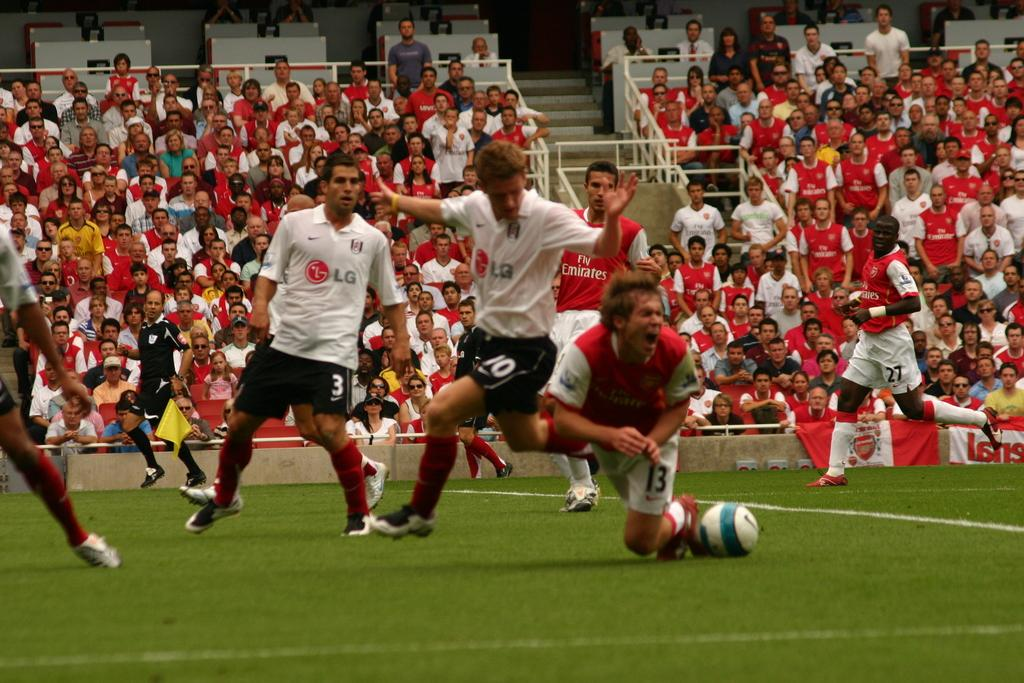What are the main subjects in the image? There are football players in the image. Can you describe the setting of the image? The image shows a football game, with spectators in the background. What type of chain can be seen connecting the players in the image? There is no chain present in the image; it features football players and spectators. 